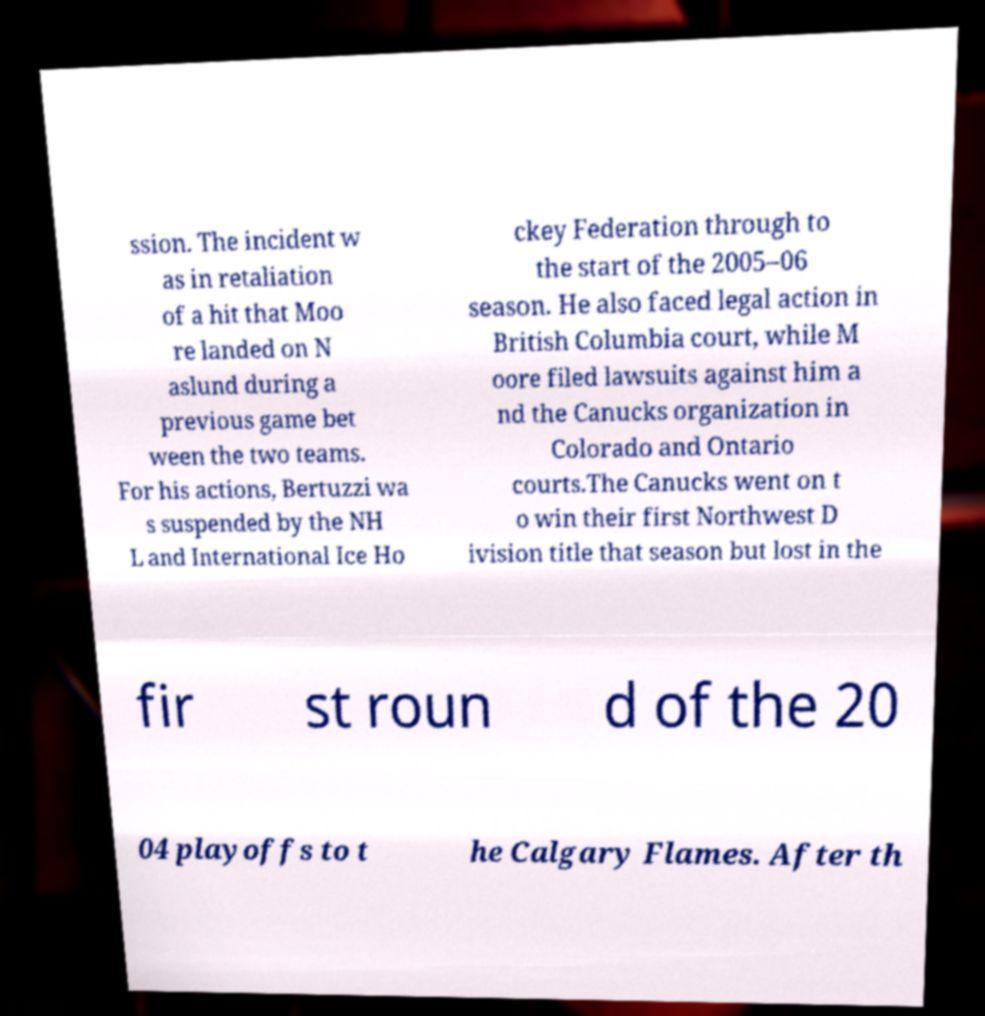I need the written content from this picture converted into text. Can you do that? ssion. The incident w as in retaliation of a hit that Moo re landed on N aslund during a previous game bet ween the two teams. For his actions, Bertuzzi wa s suspended by the NH L and International Ice Ho ckey Federation through to the start of the 2005–06 season. He also faced legal action in British Columbia court, while M oore filed lawsuits against him a nd the Canucks organization in Colorado and Ontario courts.The Canucks went on t o win their first Northwest D ivision title that season but lost in the fir st roun d of the 20 04 playoffs to t he Calgary Flames. After th 